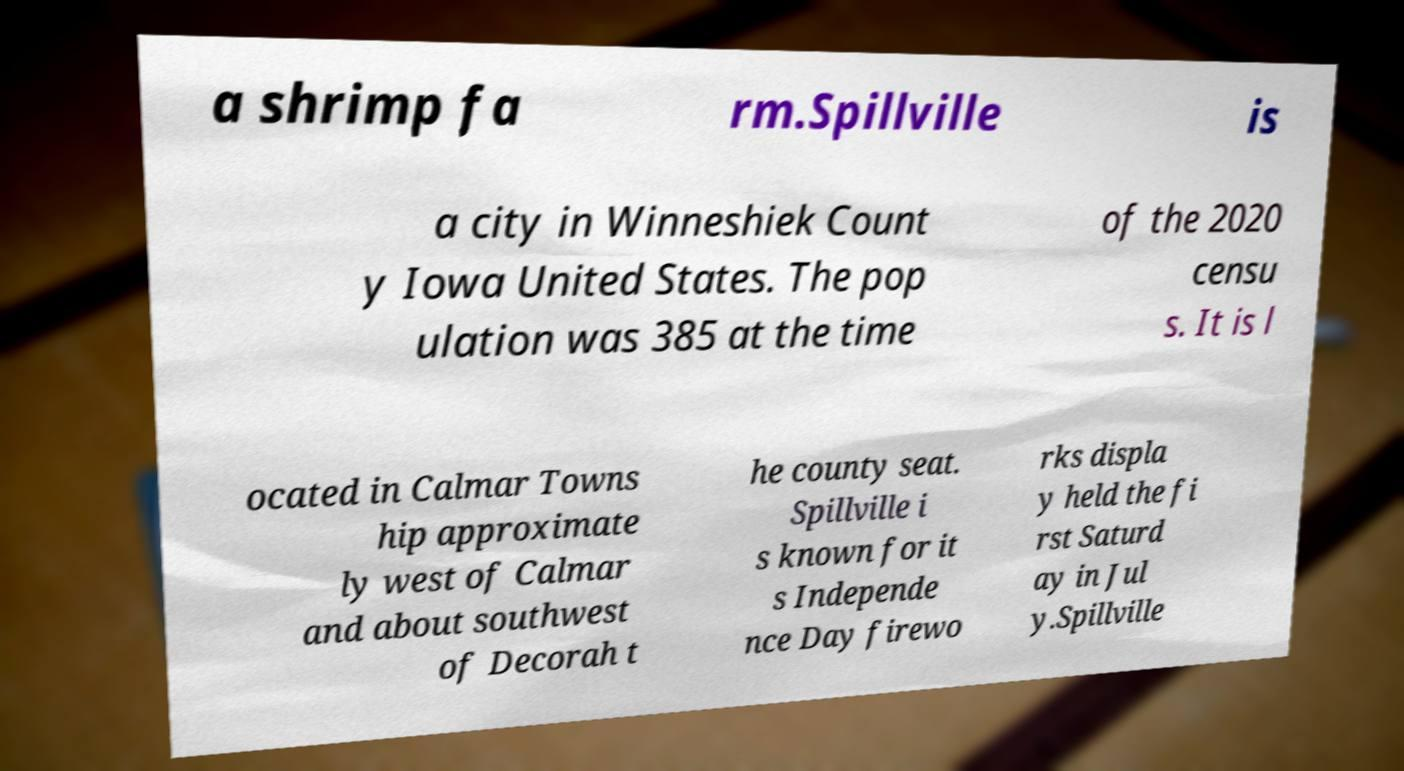I need the written content from this picture converted into text. Can you do that? a shrimp fa rm.Spillville is a city in Winneshiek Count y Iowa United States. The pop ulation was 385 at the time of the 2020 censu s. It is l ocated in Calmar Towns hip approximate ly west of Calmar and about southwest of Decorah t he county seat. Spillville i s known for it s Independe nce Day firewo rks displa y held the fi rst Saturd ay in Jul y.Spillville 